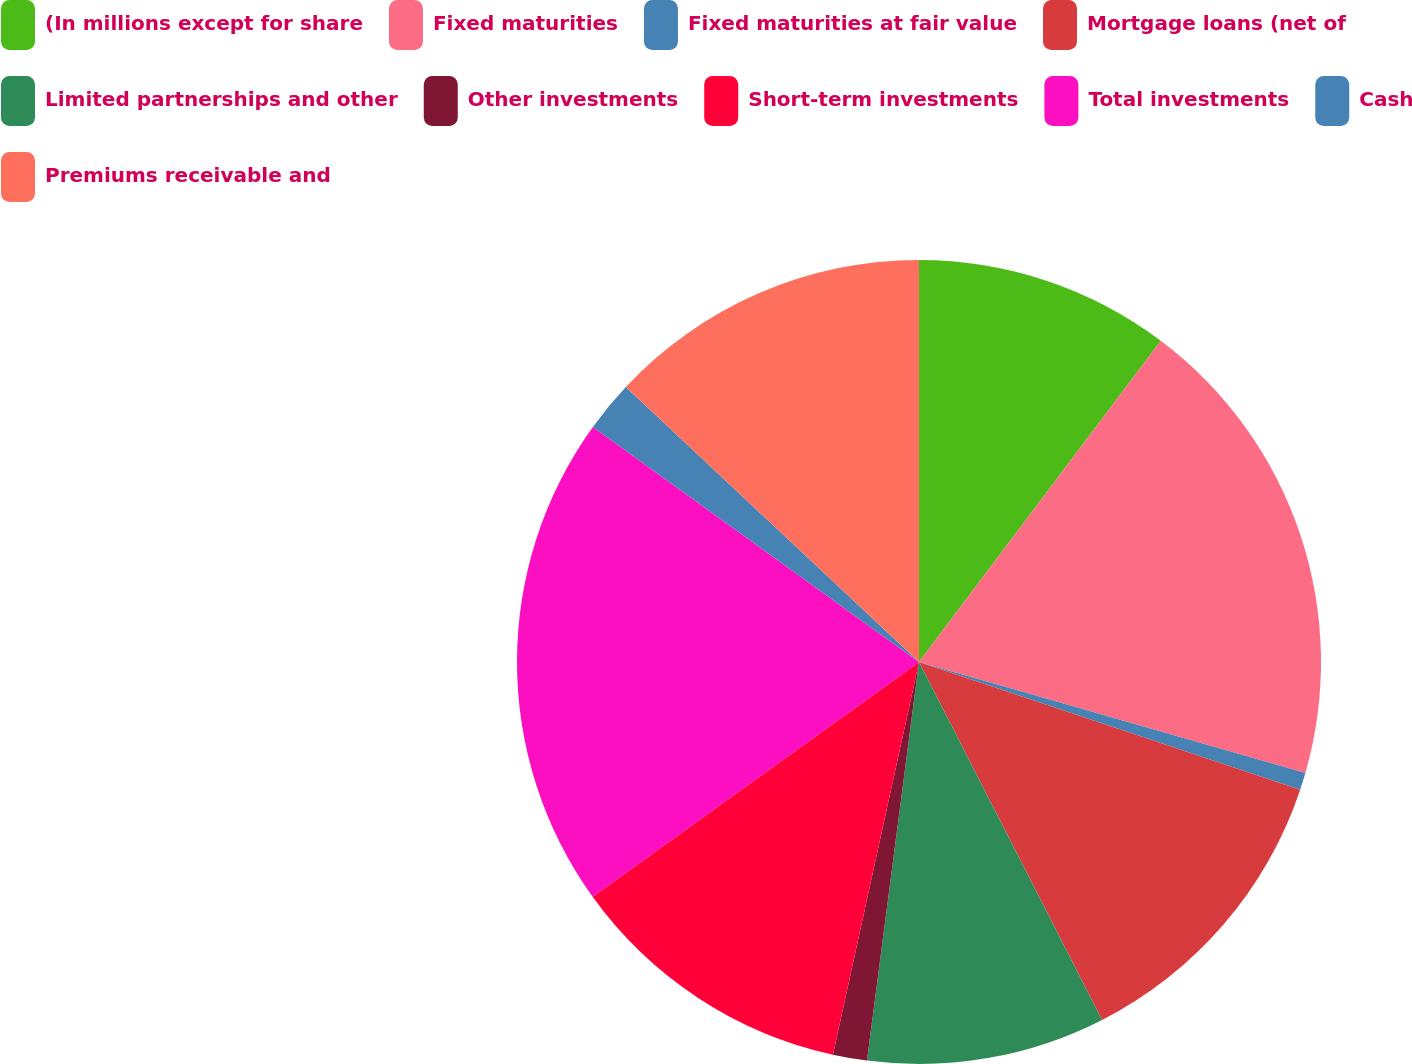<chart> <loc_0><loc_0><loc_500><loc_500><pie_chart><fcel>(In millions except for share<fcel>Fixed maturities<fcel>Fixed maturities at fair value<fcel>Mortgage loans (net of<fcel>Limited partnerships and other<fcel>Other investments<fcel>Short-term investments<fcel>Total investments<fcel>Cash<fcel>Premiums receivable and<nl><fcel>10.27%<fcel>19.18%<fcel>0.69%<fcel>12.33%<fcel>9.59%<fcel>1.37%<fcel>11.64%<fcel>19.86%<fcel>2.05%<fcel>13.01%<nl></chart> 